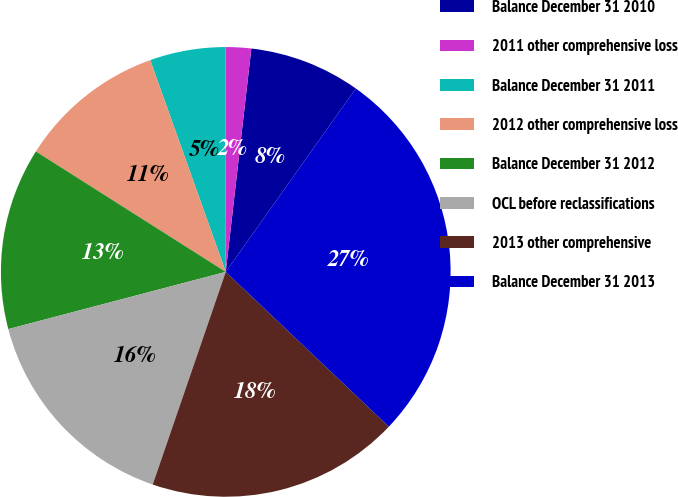Convert chart to OTSL. <chart><loc_0><loc_0><loc_500><loc_500><pie_chart><fcel>Balance December 31 2010<fcel>2011 other comprehensive loss<fcel>Balance December 31 2011<fcel>2012 other comprehensive loss<fcel>Balance December 31 2012<fcel>OCL before reclassifications<fcel>2013 other comprehensive<fcel>Balance December 31 2013<nl><fcel>8.0%<fcel>1.82%<fcel>5.45%<fcel>10.55%<fcel>13.09%<fcel>15.64%<fcel>18.18%<fcel>27.27%<nl></chart> 